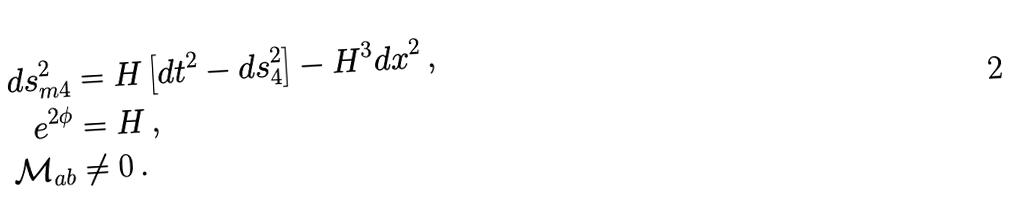Convert formula to latex. <formula><loc_0><loc_0><loc_500><loc_500>d s ^ { 2 } _ { m 4 } & = { H } \left [ d t ^ { 2 } - d s _ { 4 } ^ { 2 } \right ] - { H } ^ { 3 } d x ^ { 2 } \, , \\ e ^ { 2 \phi } & = { H } \, , \\ \mathcal { M } _ { a b } & \not = 0 \, .</formula> 